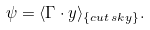Convert formula to latex. <formula><loc_0><loc_0><loc_500><loc_500>\psi = \langle { \Gamma \cdot y } \rangle _ { \{ c u t \, s k y \} } .</formula> 